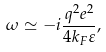<formula> <loc_0><loc_0><loc_500><loc_500>\omega \simeq - i \frac { q ^ { 2 } e ^ { 2 } } { 4 k _ { F } \varepsilon } ,</formula> 